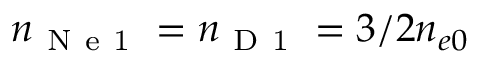<formula> <loc_0><loc_0><loc_500><loc_500>n _ { N e 1 } = n _ { D 1 } = 3 / 2 n _ { e 0 }</formula> 